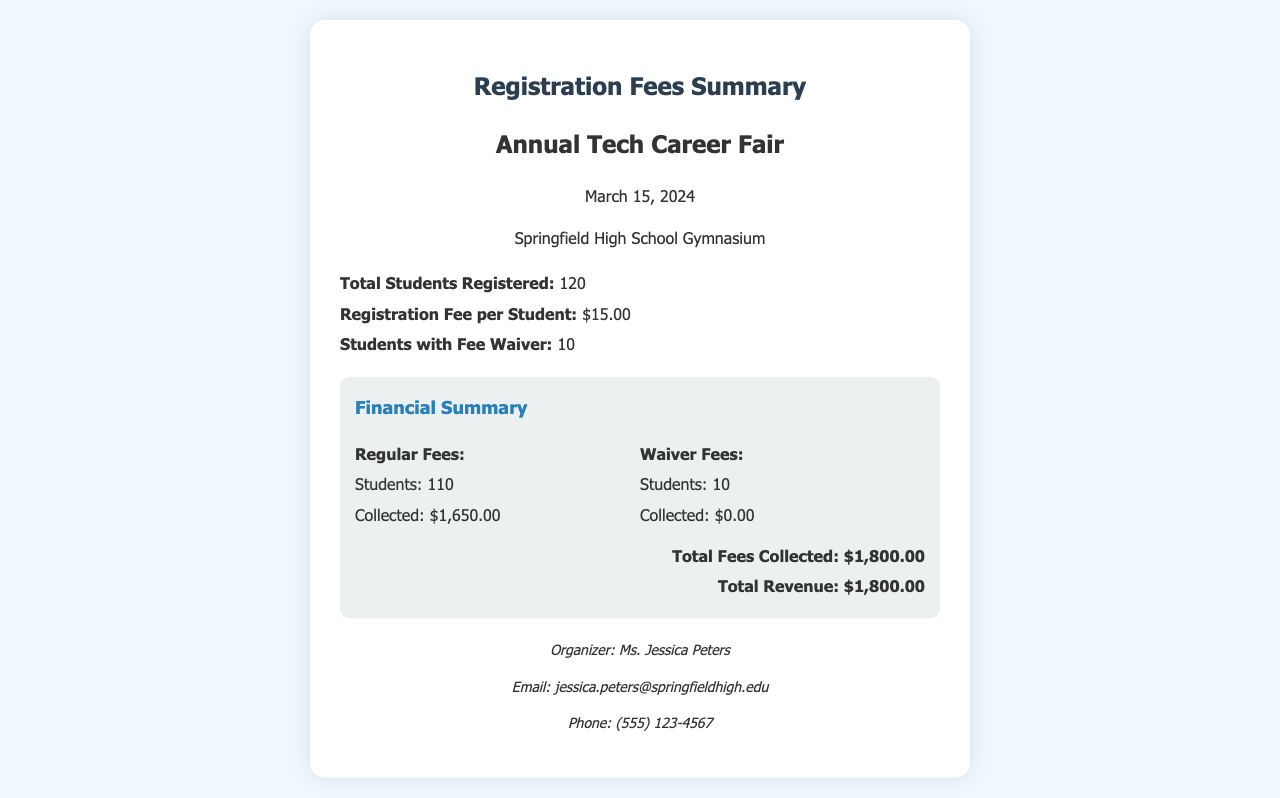What is the date of the Annual Tech Career Fair? The date is stated in the document as March 15, 2024.
Answer: March 15, 2024 How many students registered for the fair? The document specifies the total number of students registered as 120.
Answer: 120 What is the registration fee per student? The fee per student is mentioned as $15.00 in the document.
Answer: $15.00 How many students received a fee waiver? The document notes that 10 students received a fee waiver.
Answer: 10 What is the total fees collected from regular fees? The collected amount for regular fees is detailed as $1,650.00.
Answer: $1,650.00 What is the total revenue generated from the event? The total revenue is summarized in the document as $1,800.00.
Answer: $1,800.00 Who is the organizer of the event? The document lists Ms. Jessica Peters as the organizer.
Answer: Ms. Jessica Peters How many students paid the regular fees? The document specifies that 110 students paid the regular fees.
Answer: 110 What is the total number of students participating in the fair after considering waivers? The total remains the same as only the fee status is different; 120 students participated regardless of fee status.
Answer: 120 